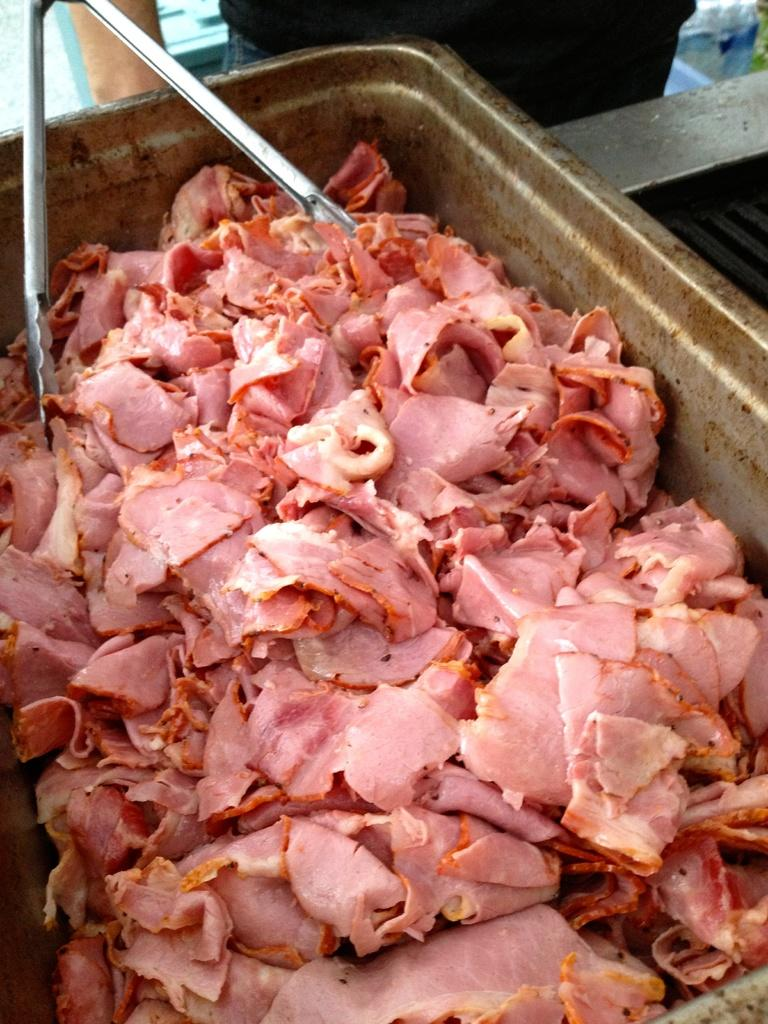What is the main object in the center of the image? There is a container in the center of the image. What is inside the container? The container has pieces of meat in it. How many objects are inside the container? There is one object in the container, which is the pieces of meat. What else can be seen in the image besides the container and its contents? There are other objects visible in the background of the image. What type of reaction can be seen in the image? There is no reaction visible in the image; it is a still image of a container with pieces of meat in it. 